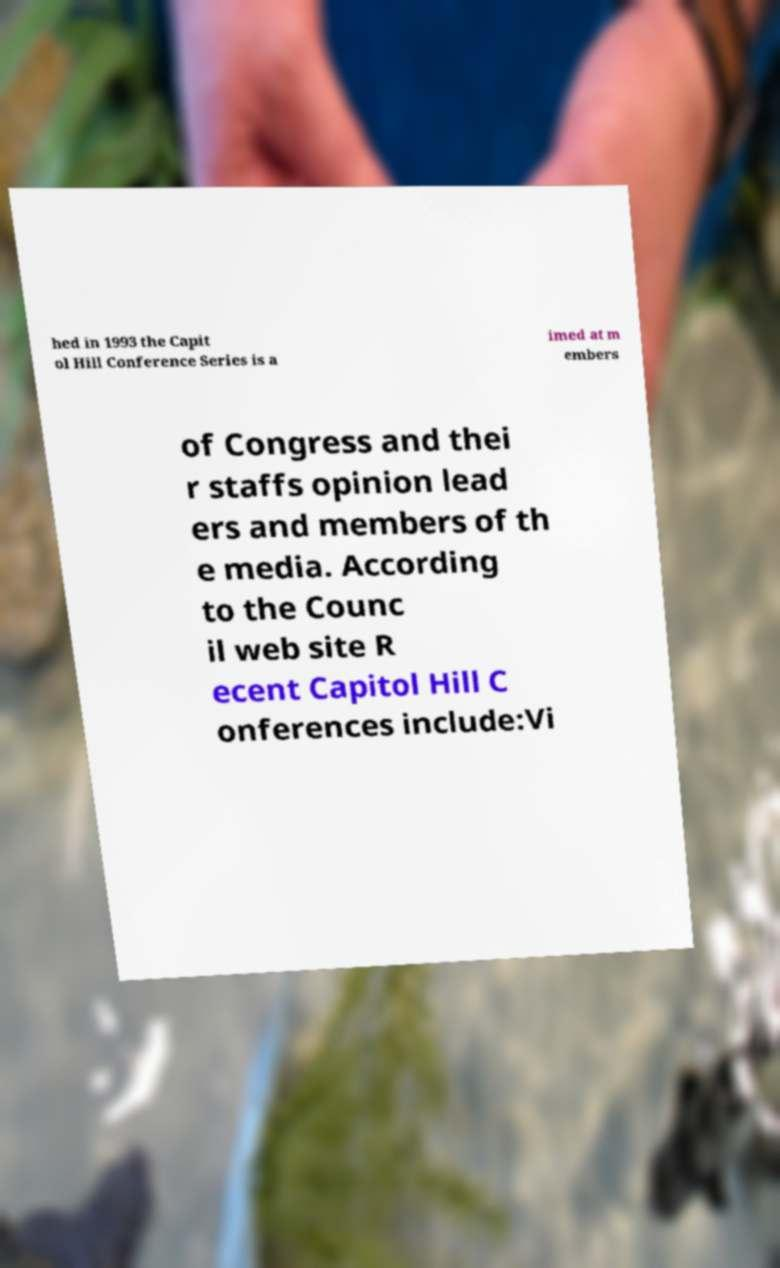Could you assist in decoding the text presented in this image and type it out clearly? hed in 1993 the Capit ol Hill Conference Series is a imed at m embers of Congress and thei r staffs opinion lead ers and members of th e media. According to the Counc il web site R ecent Capitol Hill C onferences include:Vi 